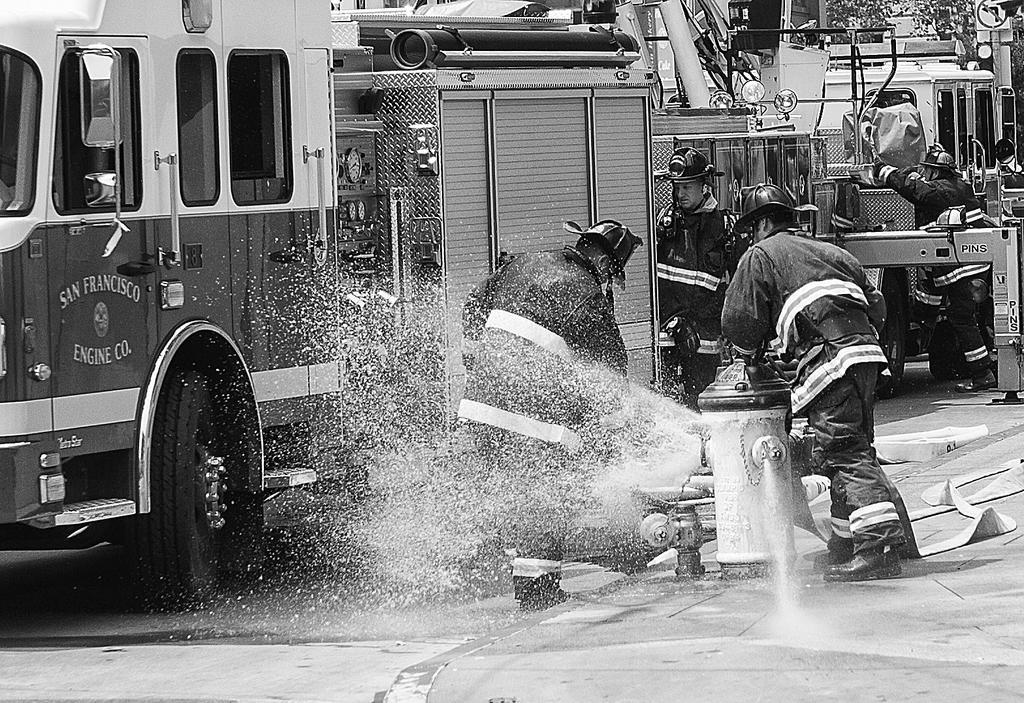Can you describe this image briefly? This picture describes about group of people, few are standing near to the water hydrant, and we can find vehicles and trees. 